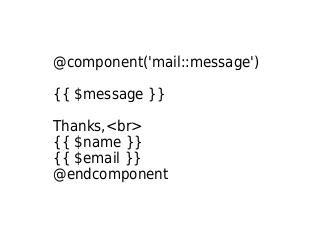Convert code to text. <code><loc_0><loc_0><loc_500><loc_500><_PHP_>@component('mail::message')

{{ $message }}

Thanks,<br>
{{ $name }}
{{ $email }}
@endcomponent
</code> 